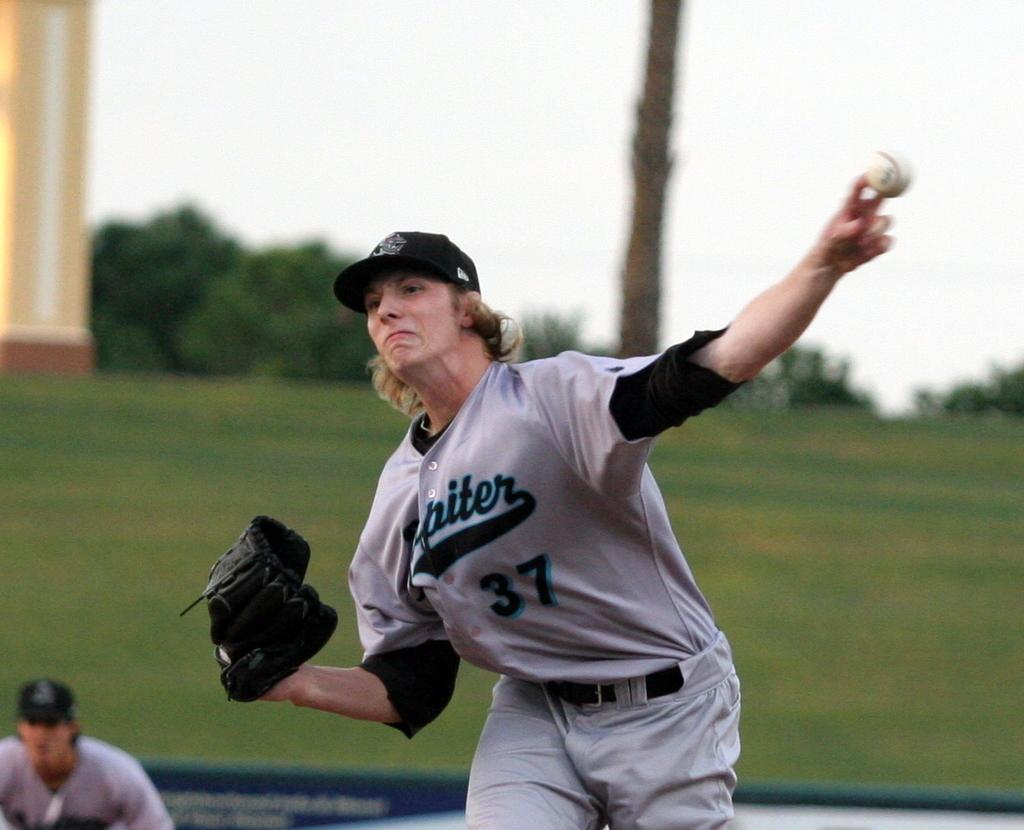What is his number?
Keep it short and to the point. 37. 